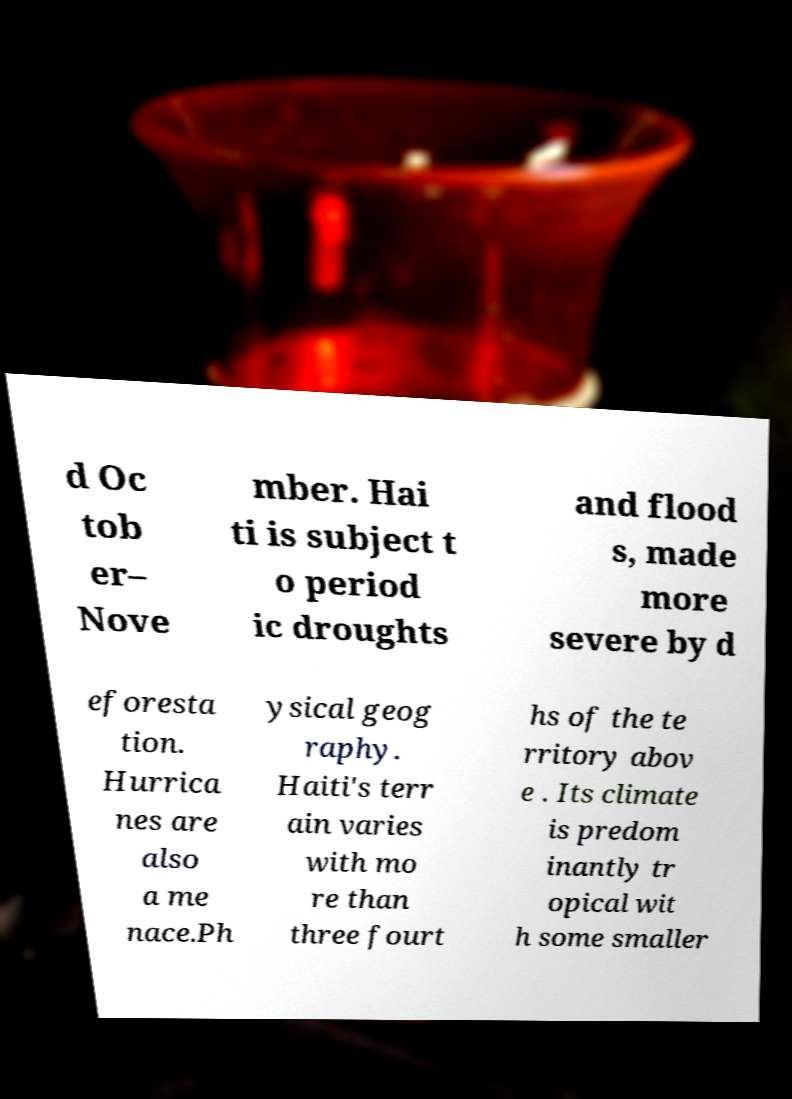Please identify and transcribe the text found in this image. d Oc tob er– Nove mber. Hai ti is subject t o period ic droughts and flood s, made more severe by d eforesta tion. Hurrica nes are also a me nace.Ph ysical geog raphy. Haiti's terr ain varies with mo re than three fourt hs of the te rritory abov e . Its climate is predom inantly tr opical wit h some smaller 